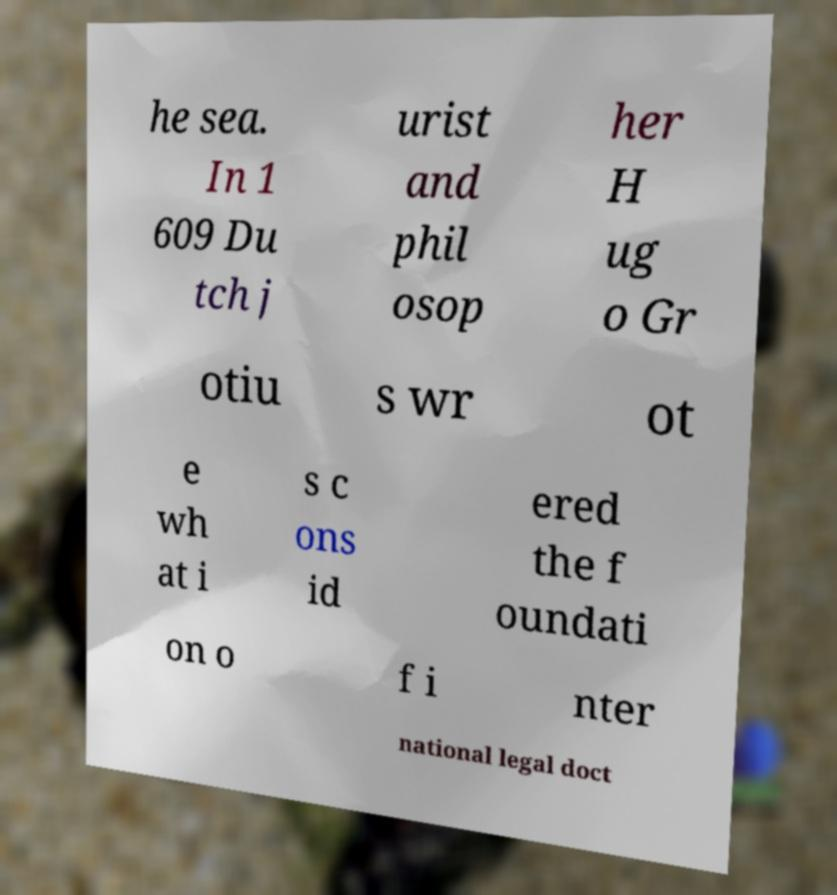Could you extract and type out the text from this image? he sea. In 1 609 Du tch j urist and phil osop her H ug o Gr otiu s wr ot e wh at i s c ons id ered the f oundati on o f i nter national legal doct 